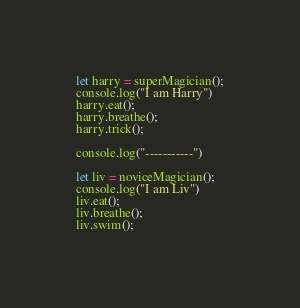<code> <loc_0><loc_0><loc_500><loc_500><_JavaScript_>let harry = superMagician();
console.log("I am Harry")
harry.eat();
harry.breathe();
harry.trick();

console.log("-----------")

let liv = noviceMagician();
console.log("I am Liv")
liv.eat();
liv.breathe();
liv.swim();</code> 